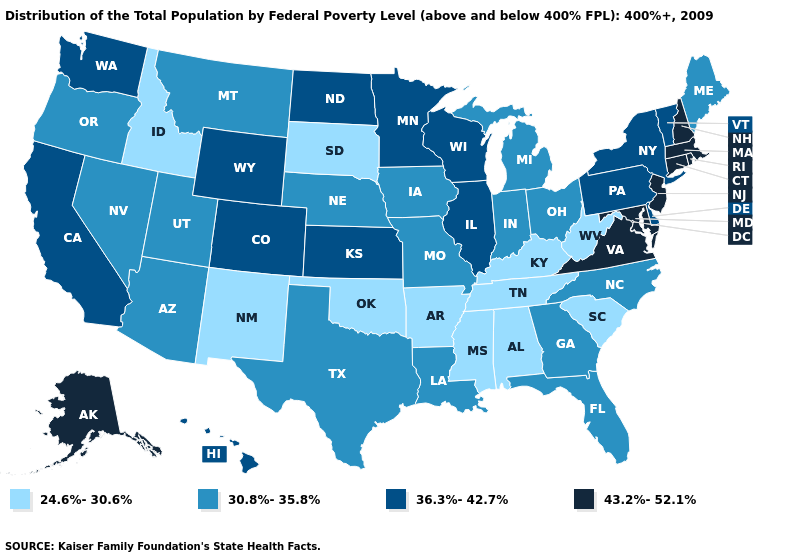What is the lowest value in the South?
Quick response, please. 24.6%-30.6%. Does Kentucky have a higher value than Maryland?
Keep it brief. No. Name the states that have a value in the range 24.6%-30.6%?
Answer briefly. Alabama, Arkansas, Idaho, Kentucky, Mississippi, New Mexico, Oklahoma, South Carolina, South Dakota, Tennessee, West Virginia. What is the value of Indiana?
Concise answer only. 30.8%-35.8%. Does Massachusetts have a higher value than Alaska?
Give a very brief answer. No. Name the states that have a value in the range 43.2%-52.1%?
Keep it brief. Alaska, Connecticut, Maryland, Massachusetts, New Hampshire, New Jersey, Rhode Island, Virginia. Name the states that have a value in the range 24.6%-30.6%?
Answer briefly. Alabama, Arkansas, Idaho, Kentucky, Mississippi, New Mexico, Oklahoma, South Carolina, South Dakota, Tennessee, West Virginia. What is the value of Nevada?
Quick response, please. 30.8%-35.8%. Among the states that border Colorado , does Arizona have the highest value?
Concise answer only. No. What is the highest value in the USA?
Keep it brief. 43.2%-52.1%. What is the lowest value in the West?
Concise answer only. 24.6%-30.6%. Name the states that have a value in the range 43.2%-52.1%?
Write a very short answer. Alaska, Connecticut, Maryland, Massachusetts, New Hampshire, New Jersey, Rhode Island, Virginia. Name the states that have a value in the range 43.2%-52.1%?
Be succinct. Alaska, Connecticut, Maryland, Massachusetts, New Hampshire, New Jersey, Rhode Island, Virginia. Name the states that have a value in the range 24.6%-30.6%?
Quick response, please. Alabama, Arkansas, Idaho, Kentucky, Mississippi, New Mexico, Oklahoma, South Carolina, South Dakota, Tennessee, West Virginia. What is the value of Kentucky?
Short answer required. 24.6%-30.6%. 